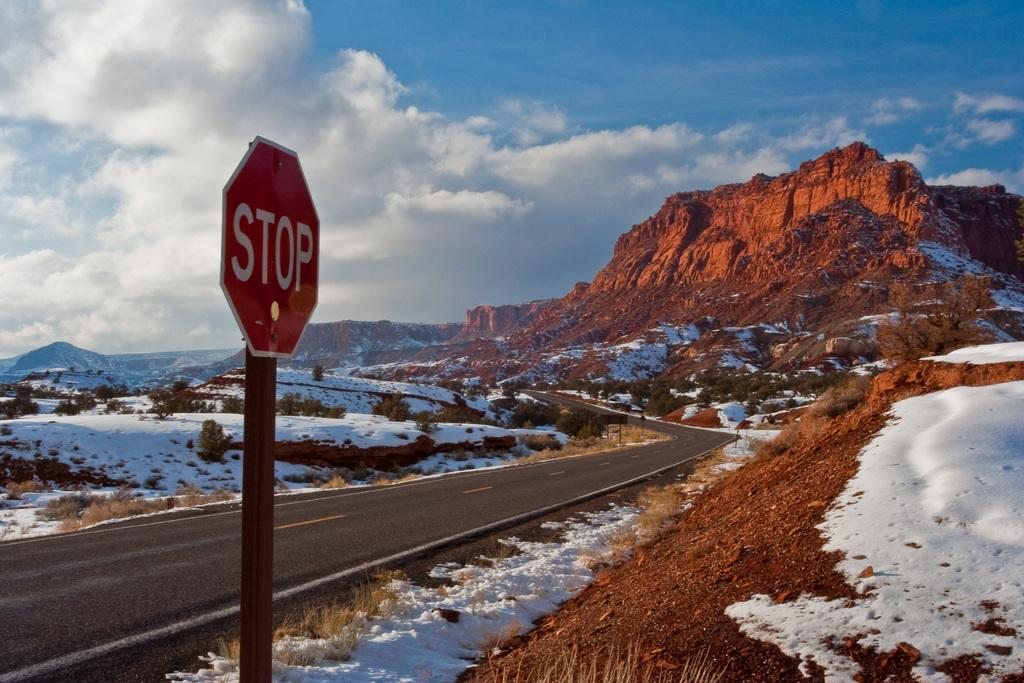<image>
Present a compact description of the photo's key features. a red stop sign outside with many mountains around 